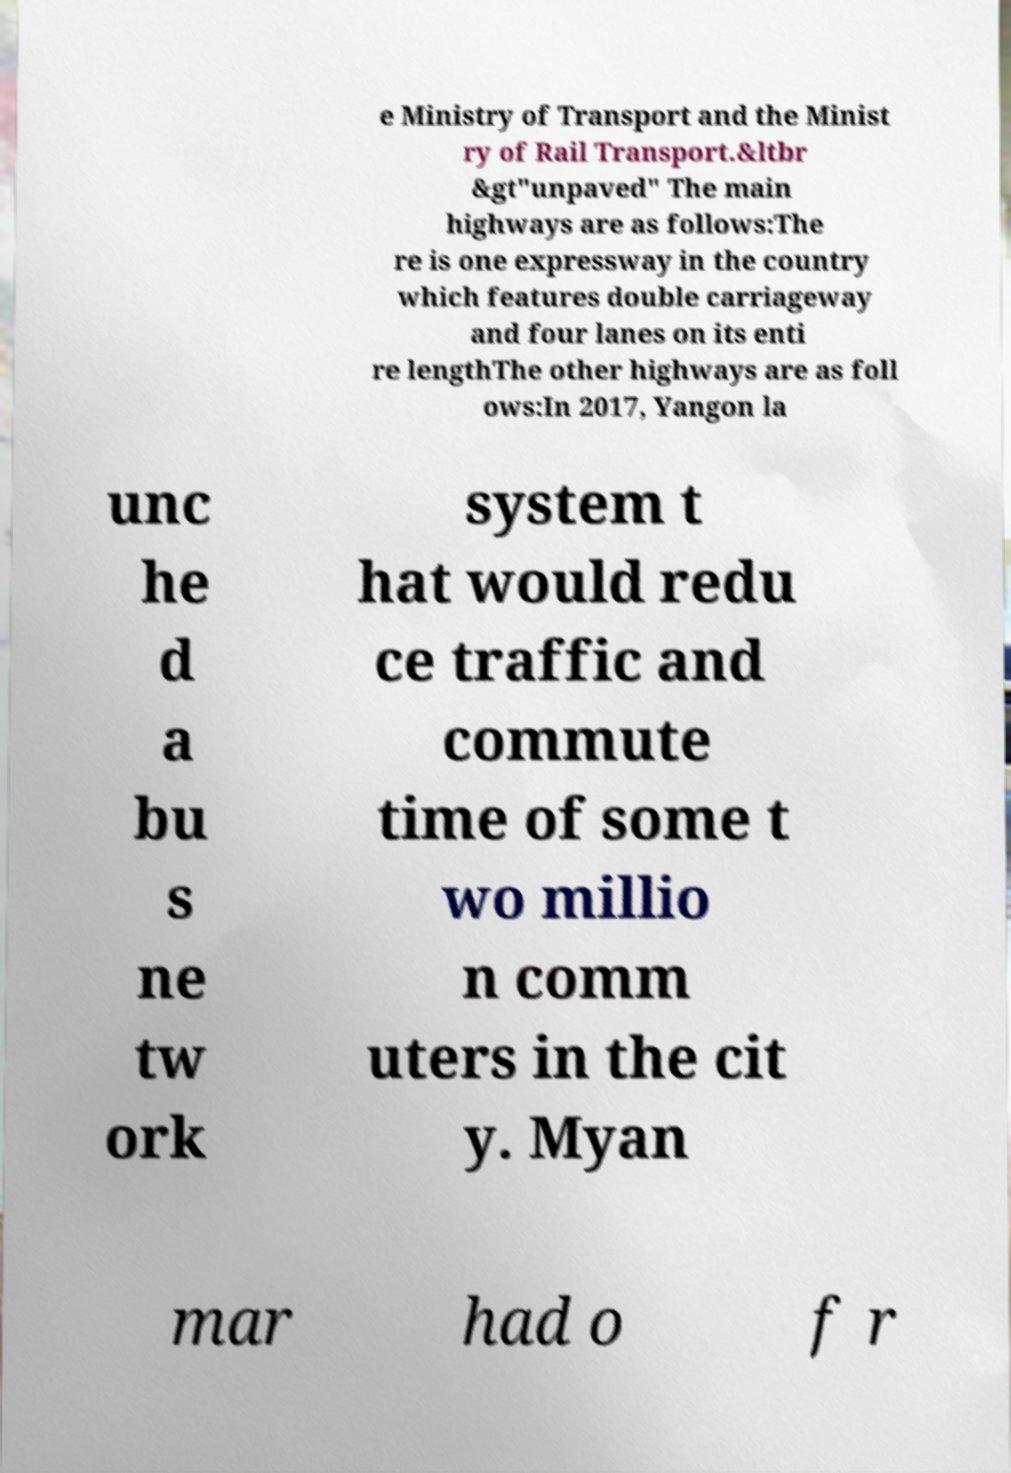Can you read and provide the text displayed in the image?This photo seems to have some interesting text. Can you extract and type it out for me? e Ministry of Transport and the Minist ry of Rail Transport.&ltbr &gt"unpaved" The main highways are as follows:The re is one expressway in the country which features double carriageway and four lanes on its enti re lengthThe other highways are as foll ows:In 2017, Yangon la unc he d a bu s ne tw ork system t hat would redu ce traffic and commute time of some t wo millio n comm uters in the cit y. Myan mar had o f r 